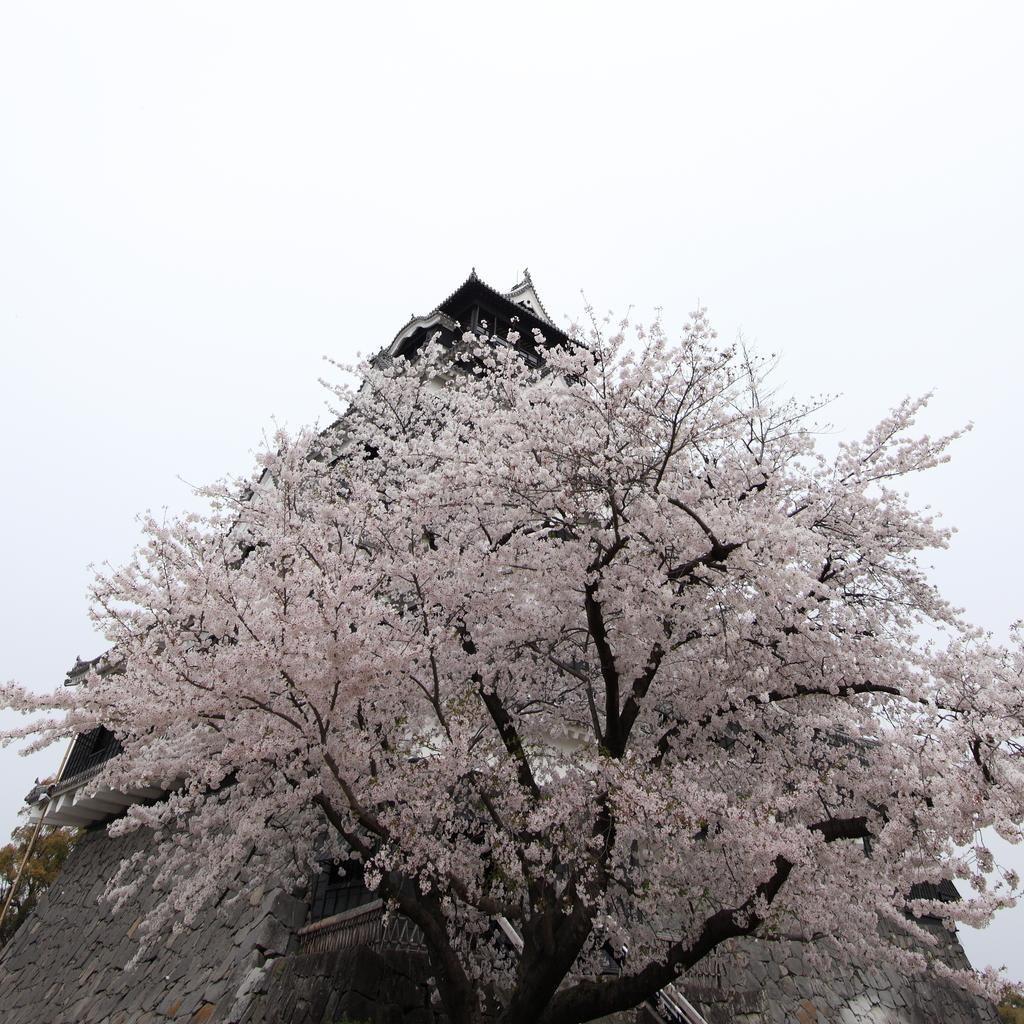What is the main subject in the middle of the image? There is a colorful tree in the middle of the image. What structure can be seen at the top of the image? There is a house at the top of the image. What is visible in the background of the image? The background of the image is the sky. Where is the cushion placed in the image? There is no cushion present in the image. What type of work is being done in the image? There is no indication of work being done in the image; it primarily features a colorful tree and a house. 